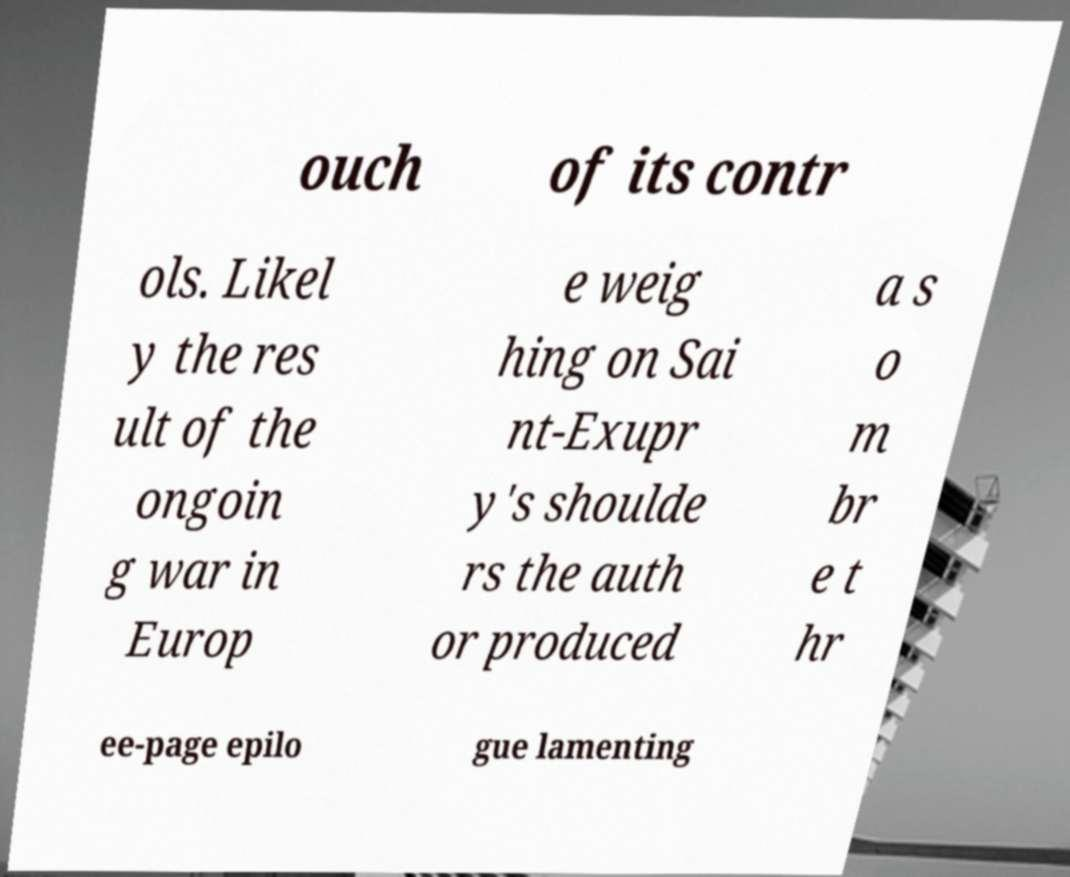Please read and relay the text visible in this image. What does it say? ouch of its contr ols. Likel y the res ult of the ongoin g war in Europ e weig hing on Sai nt-Exupr y's shoulde rs the auth or produced a s o m br e t hr ee-page epilo gue lamenting 